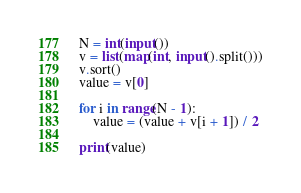Convert code to text. <code><loc_0><loc_0><loc_500><loc_500><_Python_>N = int(input())
v = list(map(int, input().split()))
v.sort()
value = v[0]

for i in range(N - 1):
    value = (value + v[i + 1]) / 2

print(value)
</code> 